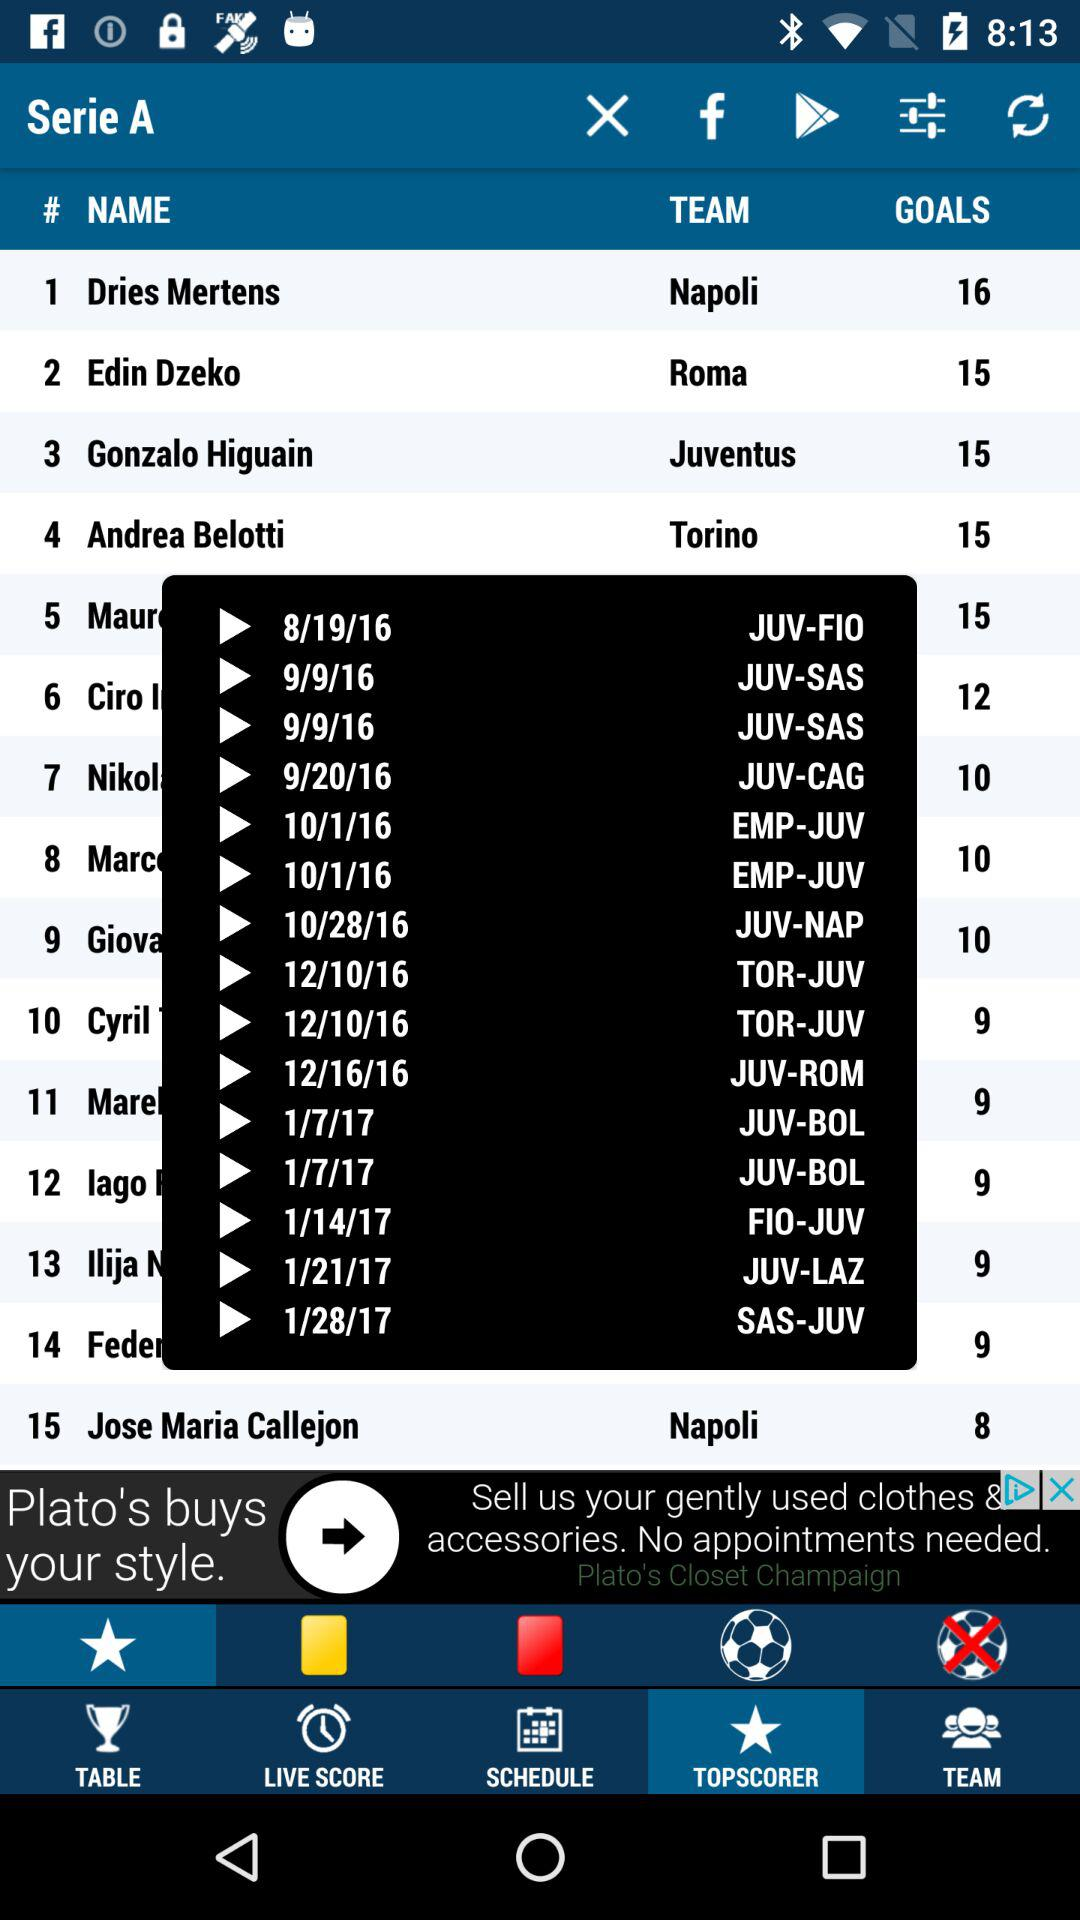Which tab is selected? The selected tab is "TOPSCORER". 